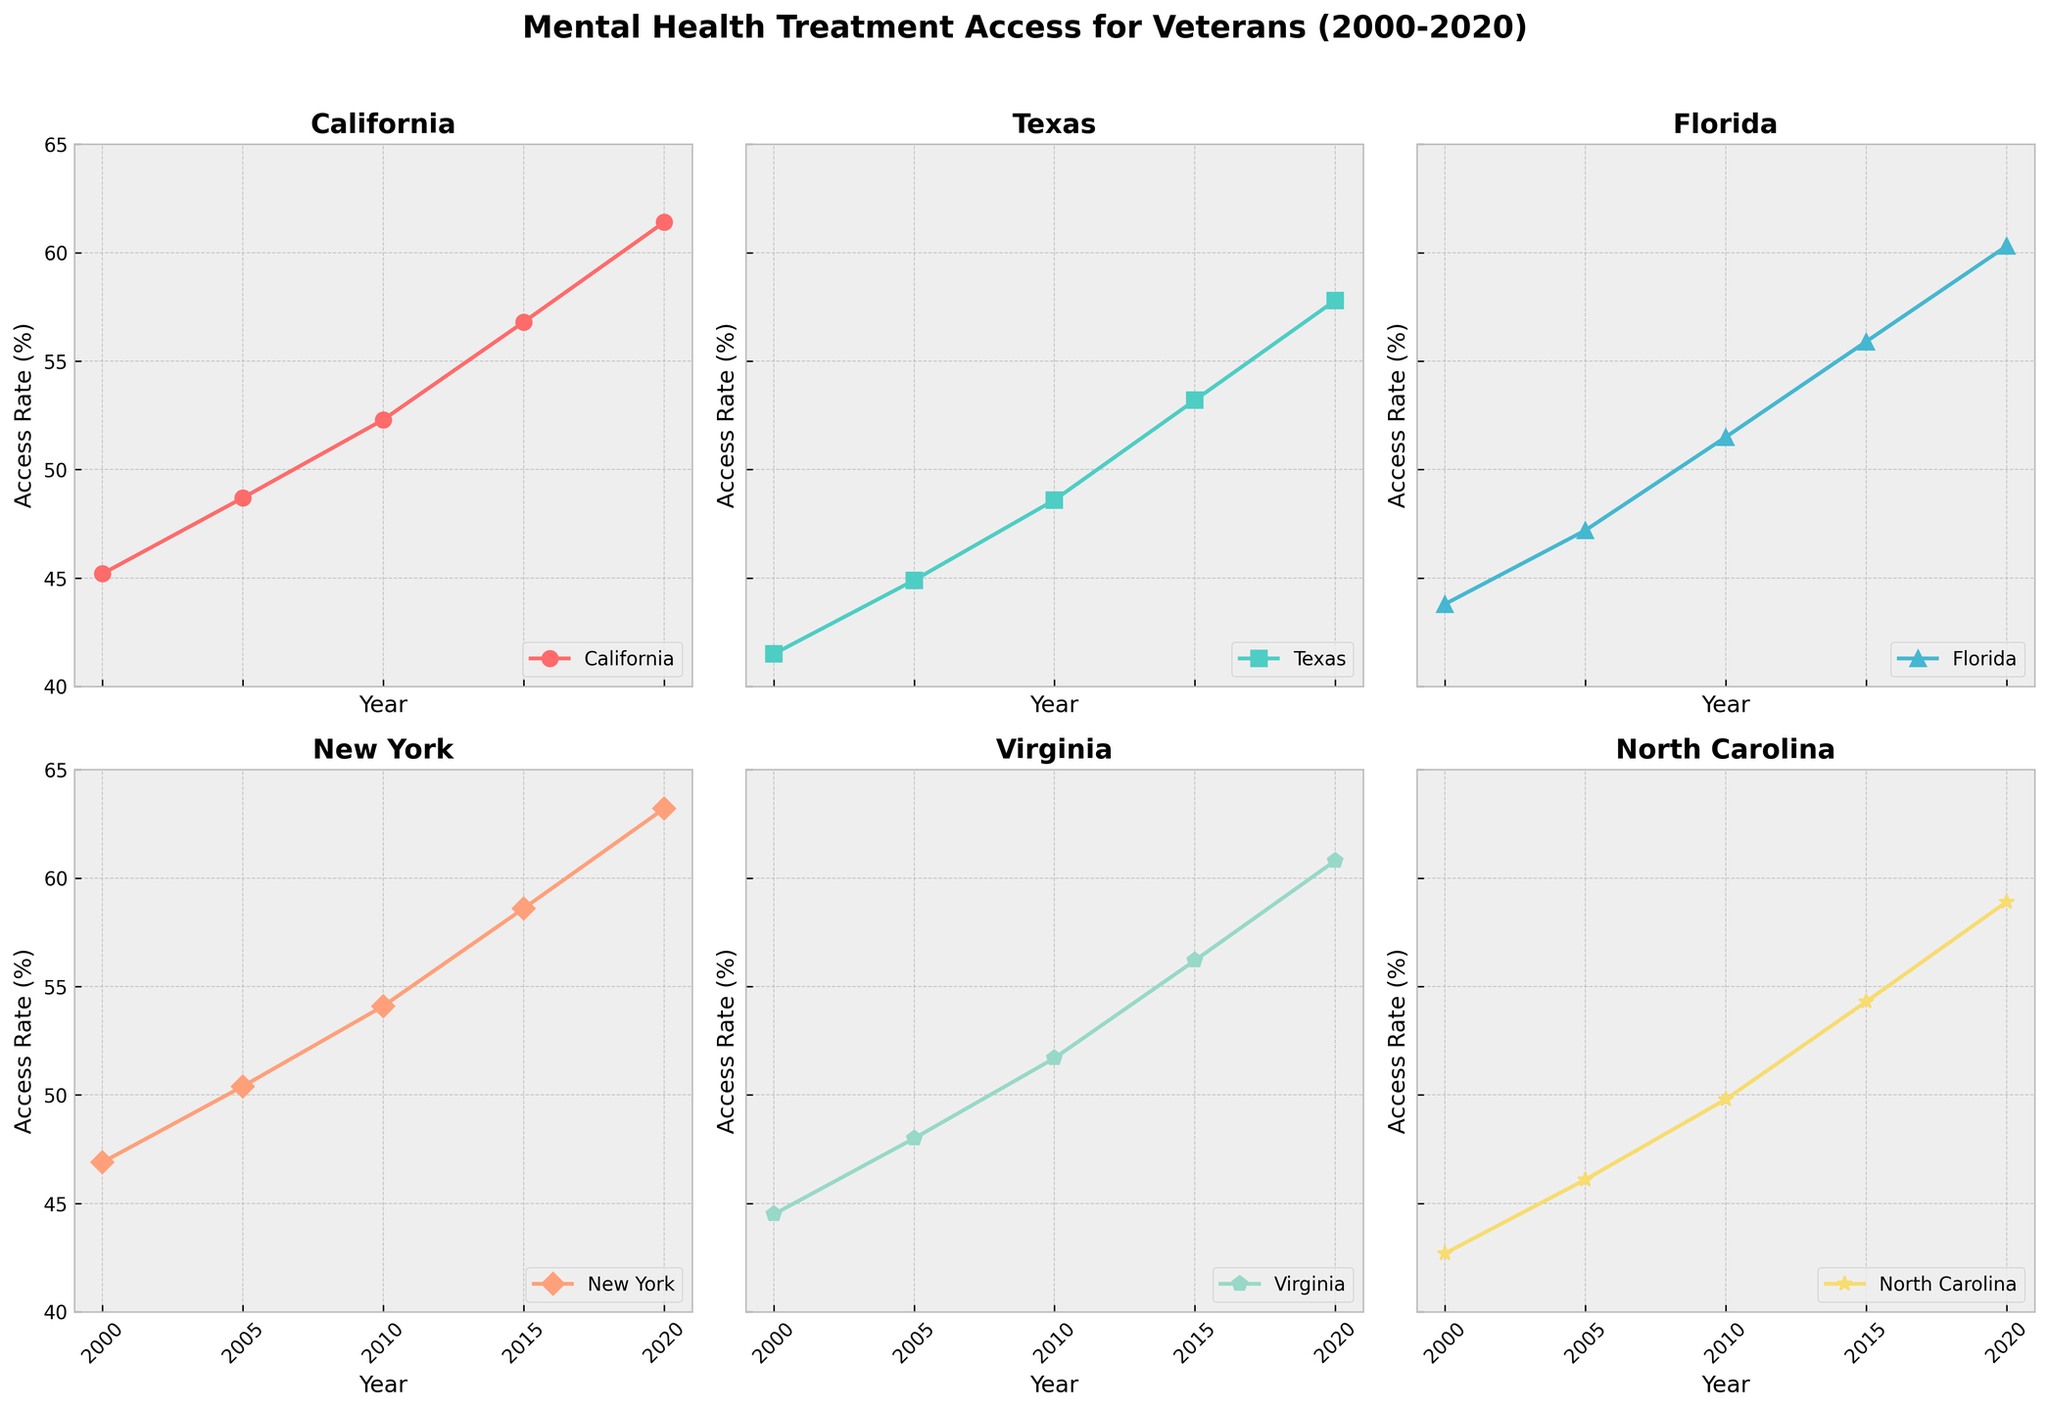Which state had the highest access rate in 2020? Look at the endpoints of the line charts and compare the access rates for all states in 2020. New York has the highest endpoint.
Answer: New York What was the overall trend in access rates from 2000 to 2020 for Texas? Observe the trend line for Texas from 2000 to 2020. The line consistently increases, indicating a rising trend in access rates.
Answer: Rising Which state had the smallest increase in mental health treatment access rate from 2000 to 2020? Calculate the difference between the 2020 and 2000 access rates for each state. California shows the largest increase, while Texas and North Carolina show smaller increases.
Answer: Texas In 2010, which state's access rate closely matched that of Virginia? Compare all states' access rates in 2010 and find which one is closest to Virginia's rate (51.7%). Florida’s rate (51.5%) is quite close to Virginia's.
Answer: Florida By how much did the access rate in California increase from 2000 to 2020? Subtract California's 2000 access rate (45.2%) from its 2020 access rate (61.4%). The increase is 61.4% - 45.2% = 16.2%.
Answer: 16.2% How did North Carolina's access in 2015 compare to that in 2005? Subtract North Carolina's 2005 access rate (46.1%) from its 2015 access rate (54.3%). The increase is 54.3% - 46.1% = 8.2%.
Answer: Increased by 8.2% Which state had the steepest increase in access rates between any two consecutive time points? Examine the slopes between each pair of consecutive years for all states. Find the largest slope. The steepest increase occurs in Texas between 2015 and 2020.
Answer: Texas (2015-2020) For New York, what is the average access rate over the given period? Sum up New York's access rates from 2000, 2005, 2010, 2015, and 2020 and divide by 5. (46.9 + 50.4 + 54.1 + 58.6 + 63.2) / 5 = 54.64.
Answer: 54.64 Which state had the most consistent increase, with similar increments between years? Compare the differences in access rates between consecutive years for each state. Virginia and Florida both show a fairly consistent increase in increments.
Answer: Virginia and Florida 